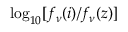<formula> <loc_0><loc_0><loc_500><loc_500>\log _ { 1 0 } [ f _ { \nu } ( i ) / f _ { \nu } ( z ) ]</formula> 